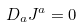<formula> <loc_0><loc_0><loc_500><loc_500>D _ { a } J ^ { a } = 0</formula> 